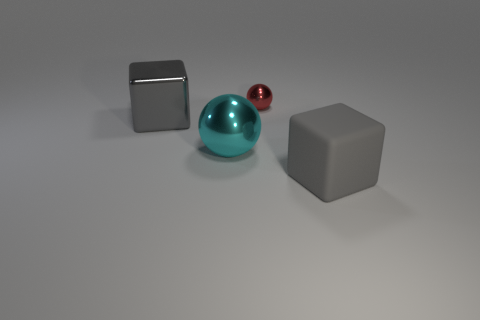There is a large matte object that is the same color as the shiny cube; what shape is it?
Make the answer very short. Cube. How many big gray cubes are there?
Your response must be concise. 2. What number of balls are tiny red things or rubber objects?
Keep it short and to the point. 1. There is a metallic cube that is the same size as the gray matte thing; what is its color?
Offer a very short reply. Gray. What number of big gray things are on the left side of the tiny red sphere and on the right side of the tiny red metal object?
Provide a short and direct response. 0. What is the big cyan ball made of?
Ensure brevity in your answer.  Metal. What number of things are large cubes or red objects?
Provide a short and direct response. 3. There is a cube that is behind the gray matte block; is its size the same as the ball that is to the left of the small red sphere?
Keep it short and to the point. Yes. How many other objects are there of the same size as the cyan sphere?
Provide a succinct answer. 2. How many things are either red things on the left side of the rubber object or gray blocks that are right of the small red sphere?
Your answer should be compact. 2. 